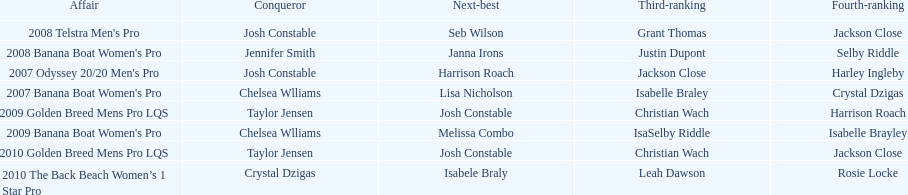Who was the leading performer in the 2008 telstra men's pro? Josh Constable. 